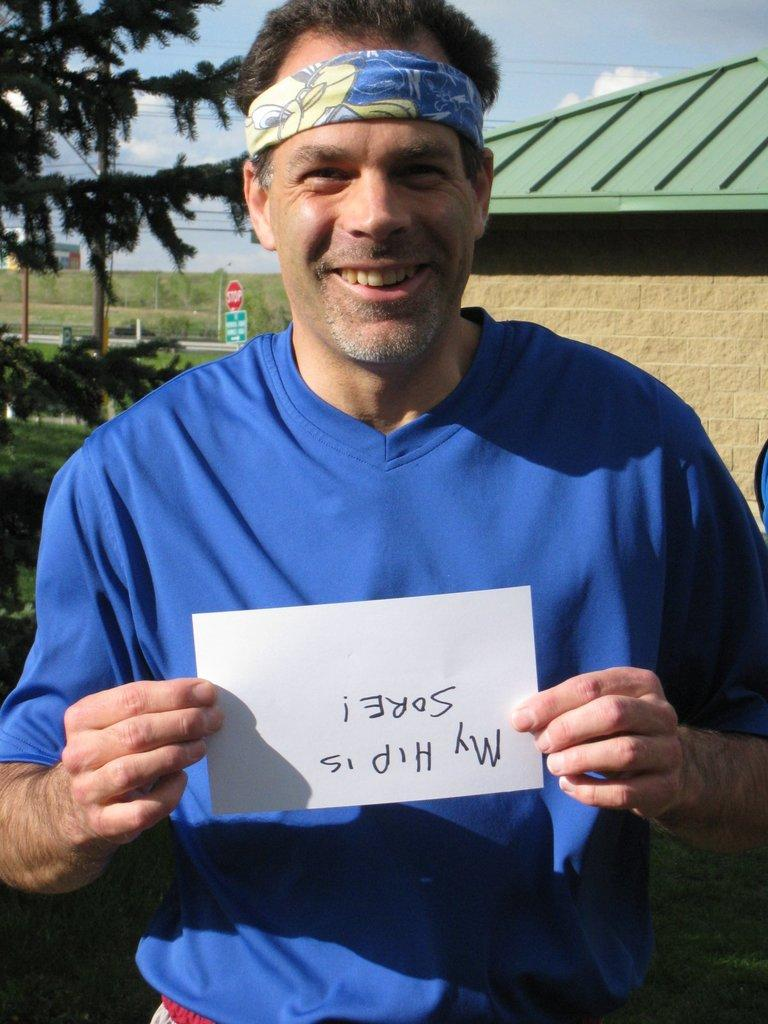Who is present in the image? There is a man in the image. What is the man wearing? The man is wearing a blue T-shirt. What is the man holding in the image? The man is holding a white paper. What can be seen in the background of the image? There is a hut, trees, and the sky visible in the background of the image. What type of eggs does the man's pet have for dinner in the image? There is no pet or mention of dinner in the image; it only features a man holding a white paper and a background with a hut, trees, and the sky. 